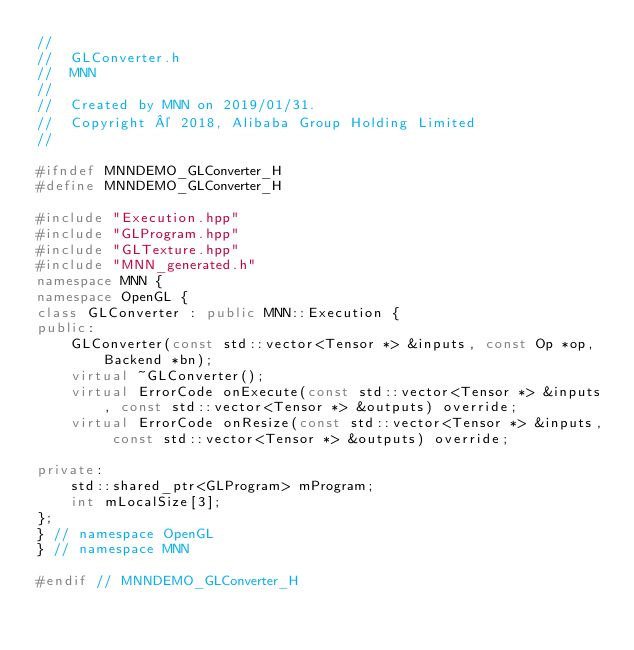<code> <loc_0><loc_0><loc_500><loc_500><_C++_>//
//  GLConverter.h
//  MNN
//
//  Created by MNN on 2019/01/31.
//  Copyright © 2018, Alibaba Group Holding Limited
//

#ifndef MNNDEMO_GLConverter_H
#define MNNDEMO_GLConverter_H

#include "Execution.hpp"
#include "GLProgram.hpp"
#include "GLTexture.hpp"
#include "MNN_generated.h"
namespace MNN {
namespace OpenGL {
class GLConverter : public MNN::Execution {
public:
    GLConverter(const std::vector<Tensor *> &inputs, const Op *op, Backend *bn);
    virtual ~GLConverter();
    virtual ErrorCode onExecute(const std::vector<Tensor *> &inputs, const std::vector<Tensor *> &outputs) override;
    virtual ErrorCode onResize(const std::vector<Tensor *> &inputs, const std::vector<Tensor *> &outputs) override;

private:
    std::shared_ptr<GLProgram> mProgram;
    int mLocalSize[3];
};
} // namespace OpenGL
} // namespace MNN

#endif // MNNDEMO_GLConverter_H
</code> 